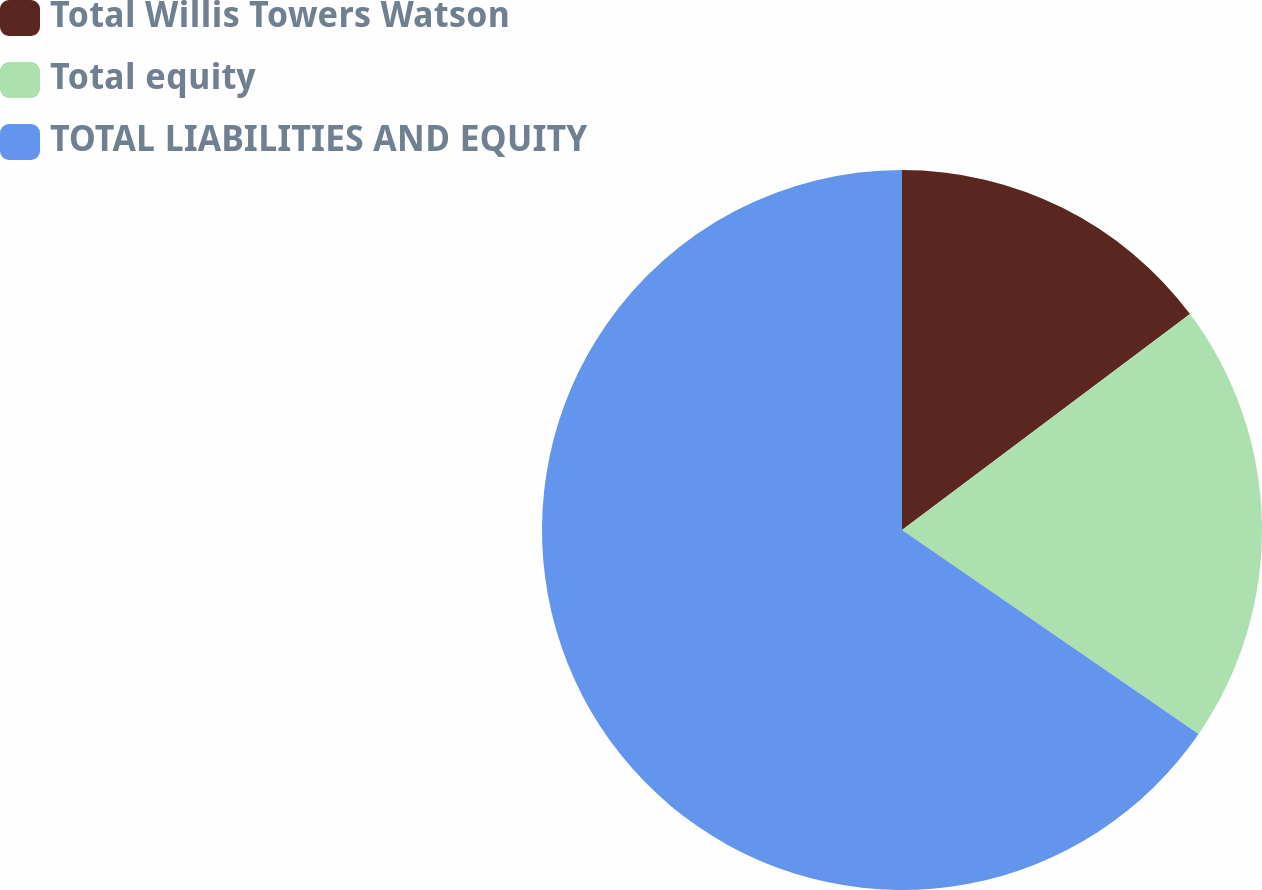Convert chart. <chart><loc_0><loc_0><loc_500><loc_500><pie_chart><fcel>Total Willis Towers Watson<fcel>Total equity<fcel>TOTAL LIABILITIES AND EQUITY<nl><fcel>14.76%<fcel>19.83%<fcel>65.41%<nl></chart> 